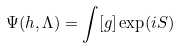Convert formula to latex. <formula><loc_0><loc_0><loc_500><loc_500>\Psi ( h , \Lambda ) = \int [ g ] \exp ( i S )</formula> 